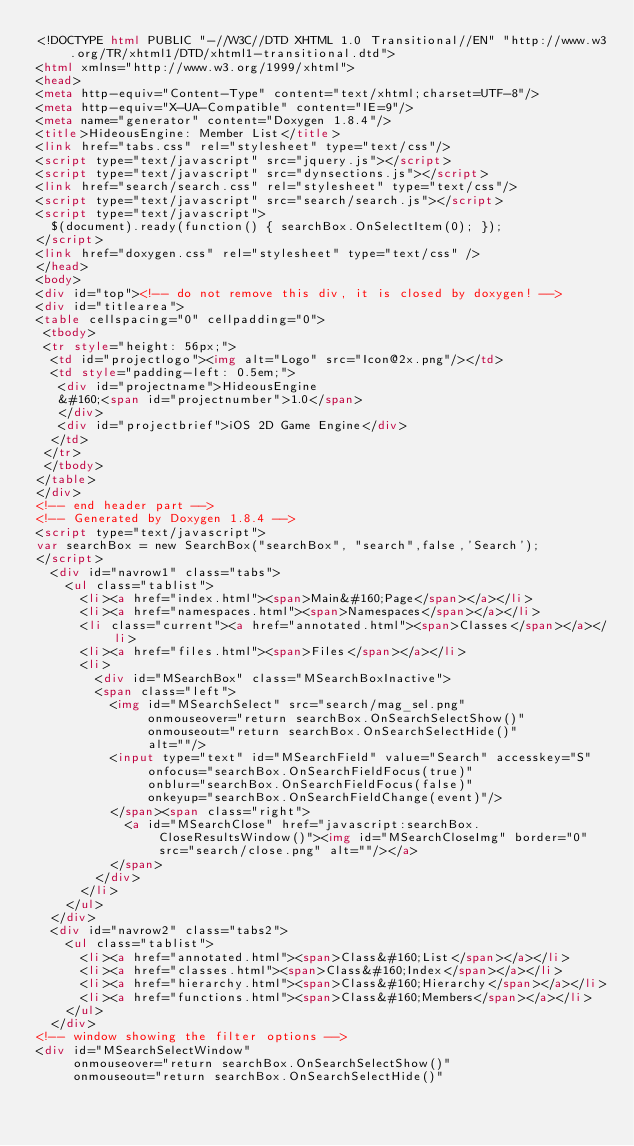Convert code to text. <code><loc_0><loc_0><loc_500><loc_500><_HTML_><!DOCTYPE html PUBLIC "-//W3C//DTD XHTML 1.0 Transitional//EN" "http://www.w3.org/TR/xhtml1/DTD/xhtml1-transitional.dtd">
<html xmlns="http://www.w3.org/1999/xhtml">
<head>
<meta http-equiv="Content-Type" content="text/xhtml;charset=UTF-8"/>
<meta http-equiv="X-UA-Compatible" content="IE=9"/>
<meta name="generator" content="Doxygen 1.8.4"/>
<title>HideousEngine: Member List</title>
<link href="tabs.css" rel="stylesheet" type="text/css"/>
<script type="text/javascript" src="jquery.js"></script>
<script type="text/javascript" src="dynsections.js"></script>
<link href="search/search.css" rel="stylesheet" type="text/css"/>
<script type="text/javascript" src="search/search.js"></script>
<script type="text/javascript">
  $(document).ready(function() { searchBox.OnSelectItem(0); });
</script>
<link href="doxygen.css" rel="stylesheet" type="text/css" />
</head>
<body>
<div id="top"><!-- do not remove this div, it is closed by doxygen! -->
<div id="titlearea">
<table cellspacing="0" cellpadding="0">
 <tbody>
 <tr style="height: 56px;">
  <td id="projectlogo"><img alt="Logo" src="Icon@2x.png"/></td>
  <td style="padding-left: 0.5em;">
   <div id="projectname">HideousEngine
   &#160;<span id="projectnumber">1.0</span>
   </div>
   <div id="projectbrief">iOS 2D Game Engine</div>
  </td>
 </tr>
 </tbody>
</table>
</div>
<!-- end header part -->
<!-- Generated by Doxygen 1.8.4 -->
<script type="text/javascript">
var searchBox = new SearchBox("searchBox", "search",false,'Search');
</script>
  <div id="navrow1" class="tabs">
    <ul class="tablist">
      <li><a href="index.html"><span>Main&#160;Page</span></a></li>
      <li><a href="namespaces.html"><span>Namespaces</span></a></li>
      <li class="current"><a href="annotated.html"><span>Classes</span></a></li>
      <li><a href="files.html"><span>Files</span></a></li>
      <li>
        <div id="MSearchBox" class="MSearchBoxInactive">
        <span class="left">
          <img id="MSearchSelect" src="search/mag_sel.png"
               onmouseover="return searchBox.OnSearchSelectShow()"
               onmouseout="return searchBox.OnSearchSelectHide()"
               alt=""/>
          <input type="text" id="MSearchField" value="Search" accesskey="S"
               onfocus="searchBox.OnSearchFieldFocus(true)" 
               onblur="searchBox.OnSearchFieldFocus(false)" 
               onkeyup="searchBox.OnSearchFieldChange(event)"/>
          </span><span class="right">
            <a id="MSearchClose" href="javascript:searchBox.CloseResultsWindow()"><img id="MSearchCloseImg" border="0" src="search/close.png" alt=""/></a>
          </span>
        </div>
      </li>
    </ul>
  </div>
  <div id="navrow2" class="tabs2">
    <ul class="tablist">
      <li><a href="annotated.html"><span>Class&#160;List</span></a></li>
      <li><a href="classes.html"><span>Class&#160;Index</span></a></li>
      <li><a href="hierarchy.html"><span>Class&#160;Hierarchy</span></a></li>
      <li><a href="functions.html"><span>Class&#160;Members</span></a></li>
    </ul>
  </div>
<!-- window showing the filter options -->
<div id="MSearchSelectWindow"
     onmouseover="return searchBox.OnSearchSelectShow()"
     onmouseout="return searchBox.OnSearchSelectHide()"</code> 